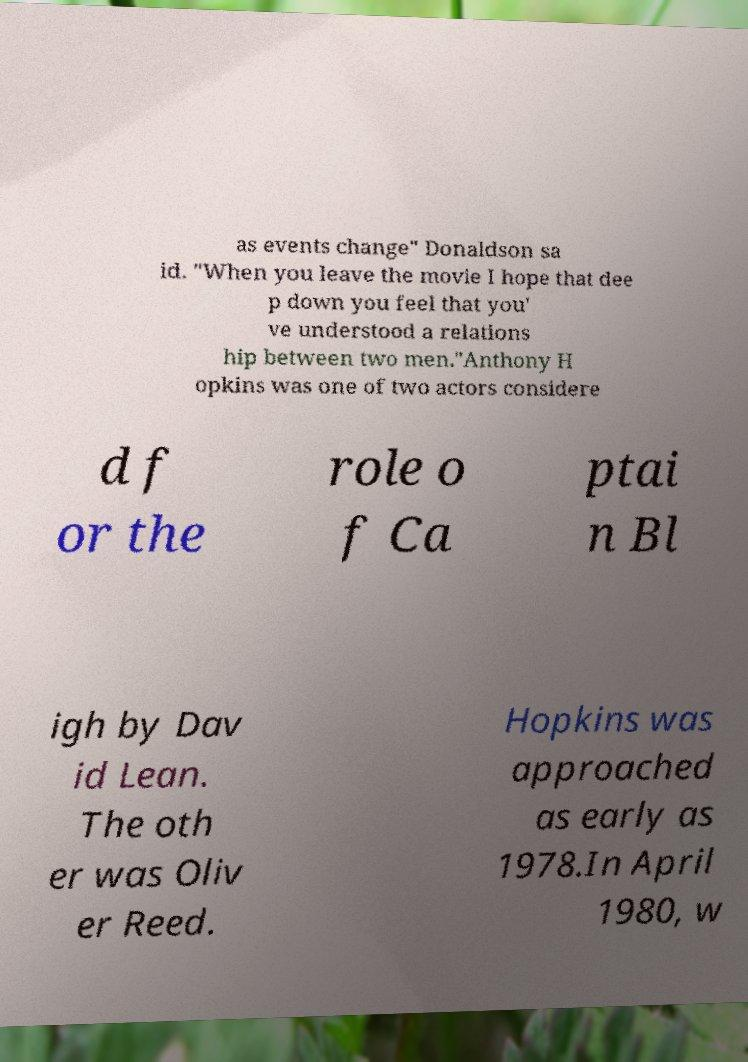For documentation purposes, I need the text within this image transcribed. Could you provide that? as events change" Donaldson sa id. "When you leave the movie I hope that dee p down you feel that you' ve understood a relations hip between two men."Anthony H opkins was one of two actors considere d f or the role o f Ca ptai n Bl igh by Dav id Lean. The oth er was Oliv er Reed. Hopkins was approached as early as 1978.In April 1980, w 